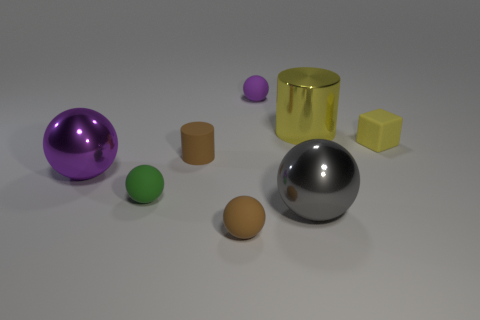What size is the rubber object that is both behind the large purple ball and to the left of the small purple matte thing?
Provide a succinct answer. Small. There is a purple ball that is in front of the block; are there any big purple things in front of it?
Offer a very short reply. No. There is a large gray metallic sphere; what number of yellow objects are to the left of it?
Give a very brief answer. 0. What is the color of the other large metal thing that is the same shape as the big purple metal object?
Your answer should be compact. Gray. Is the cylinder on the left side of the large yellow metal thing made of the same material as the purple sphere that is on the right side of the brown rubber cylinder?
Ensure brevity in your answer.  Yes. There is a cube; does it have the same color as the tiny rubber ball that is behind the tiny yellow matte block?
Keep it short and to the point. No. The object that is both to the left of the small matte cylinder and right of the big purple sphere has what shape?
Ensure brevity in your answer.  Sphere. How many large purple spheres are there?
Provide a short and direct response. 1. The tiny rubber object that is the same color as the small matte cylinder is what shape?
Your response must be concise. Sphere. What size is the brown object that is the same shape as the tiny green object?
Offer a very short reply. Small. 